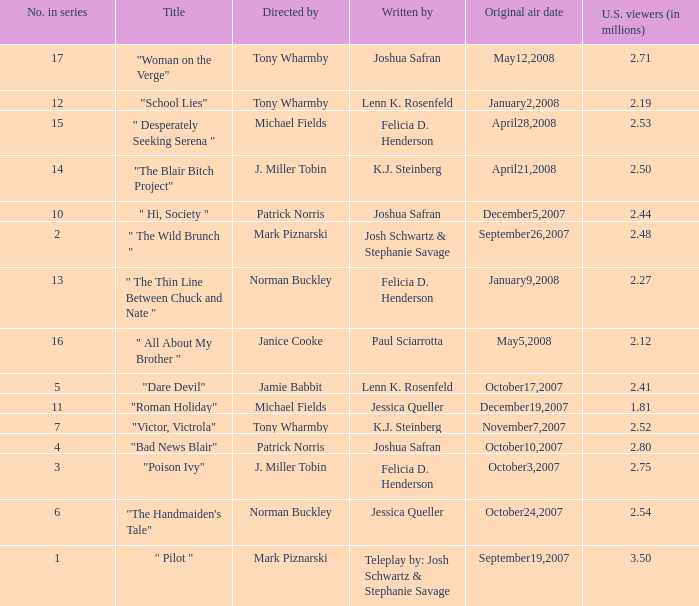How many directed by have 2.80 as u.s. viewers  (in millions)? 1.0. 